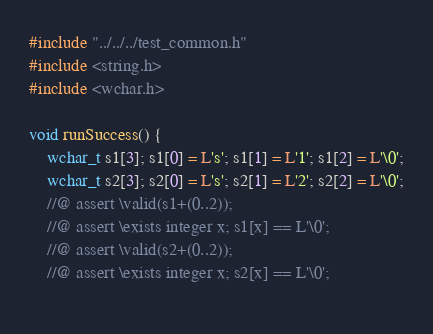Convert code to text. <code><loc_0><loc_0><loc_500><loc_500><_C_>#include "../../../test_common.h"
#include <string.h>
#include <wchar.h>

void runSuccess() {
    wchar_t s1[3]; s1[0] = L's'; s1[1] = L'1'; s1[2] = L'\0';
    wchar_t s2[3]; s2[0] = L's'; s2[1] = L'2'; s2[2] = L'\0';
    //@ assert \valid(s1+(0..2));
    //@ assert \exists integer x; s1[x] == L'\0';
    //@ assert \valid(s2+(0..2));
    //@ assert \exists integer x; s2[x] == L'\0';
    </code> 